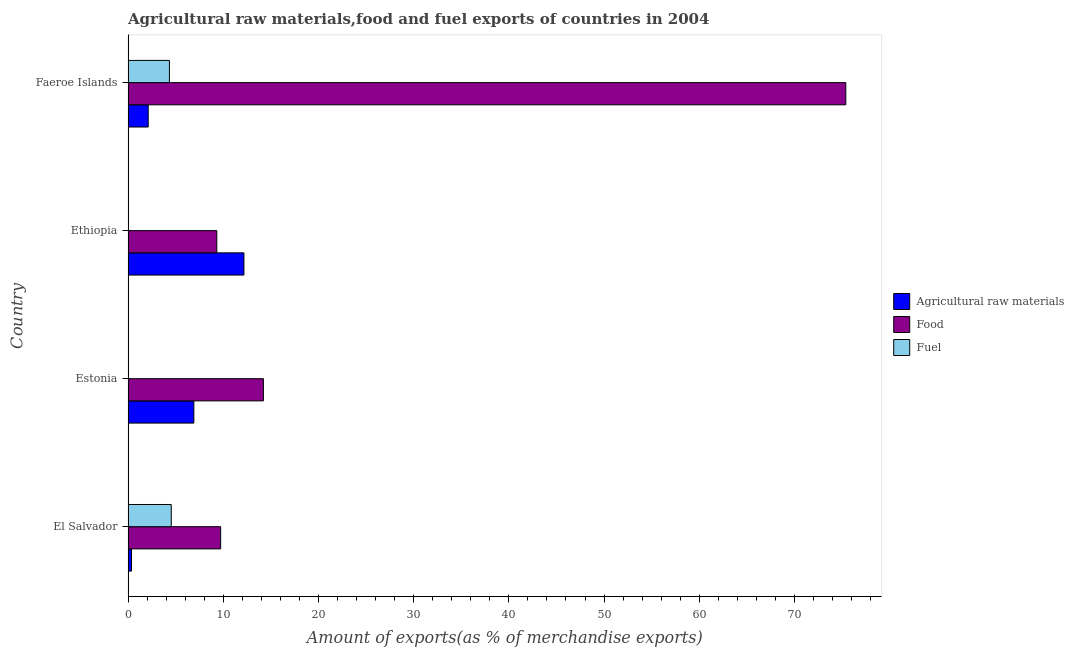Are the number of bars per tick equal to the number of legend labels?
Provide a succinct answer. Yes. Are the number of bars on each tick of the Y-axis equal?
Offer a terse response. Yes. How many bars are there on the 3rd tick from the top?
Offer a terse response. 3. How many bars are there on the 2nd tick from the bottom?
Your response must be concise. 3. What is the label of the 2nd group of bars from the top?
Offer a terse response. Ethiopia. In how many cases, is the number of bars for a given country not equal to the number of legend labels?
Your answer should be very brief. 0. What is the percentage of food exports in Faeroe Islands?
Your response must be concise. 75.39. Across all countries, what is the maximum percentage of fuel exports?
Ensure brevity in your answer.  4.54. Across all countries, what is the minimum percentage of food exports?
Provide a short and direct response. 9.32. In which country was the percentage of food exports maximum?
Ensure brevity in your answer.  Faeroe Islands. In which country was the percentage of fuel exports minimum?
Your answer should be compact. Estonia. What is the total percentage of food exports in the graph?
Give a very brief answer. 108.66. What is the difference between the percentage of raw materials exports in El Salvador and that in Faeroe Islands?
Offer a terse response. -1.76. What is the difference between the percentage of raw materials exports in Estonia and the percentage of fuel exports in Faeroe Islands?
Make the answer very short. 2.57. What is the average percentage of raw materials exports per country?
Offer a very short reply. 5.39. What is the difference between the percentage of raw materials exports and percentage of fuel exports in Estonia?
Ensure brevity in your answer.  6.91. What is the ratio of the percentage of raw materials exports in El Salvador to that in Faeroe Islands?
Your answer should be very brief. 0.17. Is the difference between the percentage of fuel exports in El Salvador and Estonia greater than the difference between the percentage of raw materials exports in El Salvador and Estonia?
Offer a terse response. Yes. What is the difference between the highest and the second highest percentage of food exports?
Make the answer very short. 61.18. What is the difference between the highest and the lowest percentage of fuel exports?
Make the answer very short. 4.53. In how many countries, is the percentage of fuel exports greater than the average percentage of fuel exports taken over all countries?
Ensure brevity in your answer.  2. Is the sum of the percentage of raw materials exports in El Salvador and Ethiopia greater than the maximum percentage of fuel exports across all countries?
Provide a succinct answer. Yes. What does the 3rd bar from the top in Ethiopia represents?
Your answer should be very brief. Agricultural raw materials. What does the 3rd bar from the bottom in Estonia represents?
Keep it short and to the point. Fuel. Are all the bars in the graph horizontal?
Offer a very short reply. Yes. What is the difference between two consecutive major ticks on the X-axis?
Your answer should be very brief. 10. Does the graph contain grids?
Make the answer very short. No. How are the legend labels stacked?
Your answer should be very brief. Vertical. What is the title of the graph?
Your answer should be compact. Agricultural raw materials,food and fuel exports of countries in 2004. What is the label or title of the X-axis?
Keep it short and to the point. Amount of exports(as % of merchandise exports). What is the label or title of the Y-axis?
Ensure brevity in your answer.  Country. What is the Amount of exports(as % of merchandise exports) in Agricultural raw materials in El Salvador?
Keep it short and to the point. 0.36. What is the Amount of exports(as % of merchandise exports) of Food in El Salvador?
Keep it short and to the point. 9.73. What is the Amount of exports(as % of merchandise exports) in Fuel in El Salvador?
Make the answer very short. 4.54. What is the Amount of exports(as % of merchandise exports) in Agricultural raw materials in Estonia?
Give a very brief answer. 6.91. What is the Amount of exports(as % of merchandise exports) in Food in Estonia?
Keep it short and to the point. 14.22. What is the Amount of exports(as % of merchandise exports) of Fuel in Estonia?
Make the answer very short. 0. What is the Amount of exports(as % of merchandise exports) of Agricultural raw materials in Ethiopia?
Provide a succinct answer. 12.17. What is the Amount of exports(as % of merchandise exports) of Food in Ethiopia?
Keep it short and to the point. 9.32. What is the Amount of exports(as % of merchandise exports) in Fuel in Ethiopia?
Provide a succinct answer. 0.01. What is the Amount of exports(as % of merchandise exports) in Agricultural raw materials in Faeroe Islands?
Keep it short and to the point. 2.12. What is the Amount of exports(as % of merchandise exports) in Food in Faeroe Islands?
Your response must be concise. 75.39. What is the Amount of exports(as % of merchandise exports) in Fuel in Faeroe Islands?
Ensure brevity in your answer.  4.34. Across all countries, what is the maximum Amount of exports(as % of merchandise exports) of Agricultural raw materials?
Ensure brevity in your answer.  12.17. Across all countries, what is the maximum Amount of exports(as % of merchandise exports) in Food?
Keep it short and to the point. 75.39. Across all countries, what is the maximum Amount of exports(as % of merchandise exports) in Fuel?
Your answer should be very brief. 4.54. Across all countries, what is the minimum Amount of exports(as % of merchandise exports) of Agricultural raw materials?
Your answer should be compact. 0.36. Across all countries, what is the minimum Amount of exports(as % of merchandise exports) of Food?
Your answer should be very brief. 9.32. Across all countries, what is the minimum Amount of exports(as % of merchandise exports) in Fuel?
Keep it short and to the point. 0. What is the total Amount of exports(as % of merchandise exports) in Agricultural raw materials in the graph?
Provide a short and direct response. 21.55. What is the total Amount of exports(as % of merchandise exports) of Food in the graph?
Provide a short and direct response. 108.66. What is the total Amount of exports(as % of merchandise exports) in Fuel in the graph?
Offer a terse response. 8.89. What is the difference between the Amount of exports(as % of merchandise exports) of Agricultural raw materials in El Salvador and that in Estonia?
Make the answer very short. -6.55. What is the difference between the Amount of exports(as % of merchandise exports) in Food in El Salvador and that in Estonia?
Make the answer very short. -4.49. What is the difference between the Amount of exports(as % of merchandise exports) of Fuel in El Salvador and that in Estonia?
Keep it short and to the point. 4.53. What is the difference between the Amount of exports(as % of merchandise exports) of Agricultural raw materials in El Salvador and that in Ethiopia?
Keep it short and to the point. -11.81. What is the difference between the Amount of exports(as % of merchandise exports) of Food in El Salvador and that in Ethiopia?
Give a very brief answer. 0.41. What is the difference between the Amount of exports(as % of merchandise exports) in Fuel in El Salvador and that in Ethiopia?
Offer a terse response. 4.53. What is the difference between the Amount of exports(as % of merchandise exports) of Agricultural raw materials in El Salvador and that in Faeroe Islands?
Give a very brief answer. -1.76. What is the difference between the Amount of exports(as % of merchandise exports) of Food in El Salvador and that in Faeroe Islands?
Provide a succinct answer. -65.67. What is the difference between the Amount of exports(as % of merchandise exports) of Fuel in El Salvador and that in Faeroe Islands?
Keep it short and to the point. 0.19. What is the difference between the Amount of exports(as % of merchandise exports) of Agricultural raw materials in Estonia and that in Ethiopia?
Provide a short and direct response. -5.26. What is the difference between the Amount of exports(as % of merchandise exports) in Food in Estonia and that in Ethiopia?
Keep it short and to the point. 4.9. What is the difference between the Amount of exports(as % of merchandise exports) in Fuel in Estonia and that in Ethiopia?
Give a very brief answer. -0. What is the difference between the Amount of exports(as % of merchandise exports) in Agricultural raw materials in Estonia and that in Faeroe Islands?
Ensure brevity in your answer.  4.79. What is the difference between the Amount of exports(as % of merchandise exports) of Food in Estonia and that in Faeroe Islands?
Provide a short and direct response. -61.18. What is the difference between the Amount of exports(as % of merchandise exports) in Fuel in Estonia and that in Faeroe Islands?
Keep it short and to the point. -4.34. What is the difference between the Amount of exports(as % of merchandise exports) of Agricultural raw materials in Ethiopia and that in Faeroe Islands?
Your answer should be compact. 10.05. What is the difference between the Amount of exports(as % of merchandise exports) of Food in Ethiopia and that in Faeroe Islands?
Offer a very short reply. -66.07. What is the difference between the Amount of exports(as % of merchandise exports) of Fuel in Ethiopia and that in Faeroe Islands?
Your answer should be very brief. -4.33. What is the difference between the Amount of exports(as % of merchandise exports) of Agricultural raw materials in El Salvador and the Amount of exports(as % of merchandise exports) of Food in Estonia?
Give a very brief answer. -13.86. What is the difference between the Amount of exports(as % of merchandise exports) of Agricultural raw materials in El Salvador and the Amount of exports(as % of merchandise exports) of Fuel in Estonia?
Provide a succinct answer. 0.35. What is the difference between the Amount of exports(as % of merchandise exports) of Food in El Salvador and the Amount of exports(as % of merchandise exports) of Fuel in Estonia?
Provide a succinct answer. 9.72. What is the difference between the Amount of exports(as % of merchandise exports) of Agricultural raw materials in El Salvador and the Amount of exports(as % of merchandise exports) of Food in Ethiopia?
Give a very brief answer. -8.96. What is the difference between the Amount of exports(as % of merchandise exports) of Agricultural raw materials in El Salvador and the Amount of exports(as % of merchandise exports) of Fuel in Ethiopia?
Offer a very short reply. 0.35. What is the difference between the Amount of exports(as % of merchandise exports) in Food in El Salvador and the Amount of exports(as % of merchandise exports) in Fuel in Ethiopia?
Your answer should be compact. 9.72. What is the difference between the Amount of exports(as % of merchandise exports) in Agricultural raw materials in El Salvador and the Amount of exports(as % of merchandise exports) in Food in Faeroe Islands?
Your answer should be very brief. -75.04. What is the difference between the Amount of exports(as % of merchandise exports) of Agricultural raw materials in El Salvador and the Amount of exports(as % of merchandise exports) of Fuel in Faeroe Islands?
Your answer should be very brief. -3.98. What is the difference between the Amount of exports(as % of merchandise exports) of Food in El Salvador and the Amount of exports(as % of merchandise exports) of Fuel in Faeroe Islands?
Provide a succinct answer. 5.38. What is the difference between the Amount of exports(as % of merchandise exports) in Agricultural raw materials in Estonia and the Amount of exports(as % of merchandise exports) in Food in Ethiopia?
Keep it short and to the point. -2.41. What is the difference between the Amount of exports(as % of merchandise exports) of Agricultural raw materials in Estonia and the Amount of exports(as % of merchandise exports) of Fuel in Ethiopia?
Keep it short and to the point. 6.9. What is the difference between the Amount of exports(as % of merchandise exports) in Food in Estonia and the Amount of exports(as % of merchandise exports) in Fuel in Ethiopia?
Make the answer very short. 14.21. What is the difference between the Amount of exports(as % of merchandise exports) in Agricultural raw materials in Estonia and the Amount of exports(as % of merchandise exports) in Food in Faeroe Islands?
Offer a very short reply. -68.48. What is the difference between the Amount of exports(as % of merchandise exports) of Agricultural raw materials in Estonia and the Amount of exports(as % of merchandise exports) of Fuel in Faeroe Islands?
Give a very brief answer. 2.57. What is the difference between the Amount of exports(as % of merchandise exports) of Food in Estonia and the Amount of exports(as % of merchandise exports) of Fuel in Faeroe Islands?
Provide a short and direct response. 9.87. What is the difference between the Amount of exports(as % of merchandise exports) of Agricultural raw materials in Ethiopia and the Amount of exports(as % of merchandise exports) of Food in Faeroe Islands?
Keep it short and to the point. -63.22. What is the difference between the Amount of exports(as % of merchandise exports) of Agricultural raw materials in Ethiopia and the Amount of exports(as % of merchandise exports) of Fuel in Faeroe Islands?
Make the answer very short. 7.83. What is the difference between the Amount of exports(as % of merchandise exports) in Food in Ethiopia and the Amount of exports(as % of merchandise exports) in Fuel in Faeroe Islands?
Keep it short and to the point. 4.98. What is the average Amount of exports(as % of merchandise exports) in Agricultural raw materials per country?
Your answer should be very brief. 5.39. What is the average Amount of exports(as % of merchandise exports) of Food per country?
Make the answer very short. 27.16. What is the average Amount of exports(as % of merchandise exports) in Fuel per country?
Your answer should be compact. 2.22. What is the difference between the Amount of exports(as % of merchandise exports) in Agricultural raw materials and Amount of exports(as % of merchandise exports) in Food in El Salvador?
Provide a short and direct response. -9.37. What is the difference between the Amount of exports(as % of merchandise exports) of Agricultural raw materials and Amount of exports(as % of merchandise exports) of Fuel in El Salvador?
Offer a very short reply. -4.18. What is the difference between the Amount of exports(as % of merchandise exports) of Food and Amount of exports(as % of merchandise exports) of Fuel in El Salvador?
Your response must be concise. 5.19. What is the difference between the Amount of exports(as % of merchandise exports) of Agricultural raw materials and Amount of exports(as % of merchandise exports) of Food in Estonia?
Offer a terse response. -7.31. What is the difference between the Amount of exports(as % of merchandise exports) of Agricultural raw materials and Amount of exports(as % of merchandise exports) of Fuel in Estonia?
Provide a succinct answer. 6.9. What is the difference between the Amount of exports(as % of merchandise exports) in Food and Amount of exports(as % of merchandise exports) in Fuel in Estonia?
Your answer should be compact. 14.21. What is the difference between the Amount of exports(as % of merchandise exports) in Agricultural raw materials and Amount of exports(as % of merchandise exports) in Food in Ethiopia?
Keep it short and to the point. 2.85. What is the difference between the Amount of exports(as % of merchandise exports) of Agricultural raw materials and Amount of exports(as % of merchandise exports) of Fuel in Ethiopia?
Your answer should be compact. 12.16. What is the difference between the Amount of exports(as % of merchandise exports) of Food and Amount of exports(as % of merchandise exports) of Fuel in Ethiopia?
Provide a short and direct response. 9.31. What is the difference between the Amount of exports(as % of merchandise exports) in Agricultural raw materials and Amount of exports(as % of merchandise exports) in Food in Faeroe Islands?
Make the answer very short. -73.28. What is the difference between the Amount of exports(as % of merchandise exports) of Agricultural raw materials and Amount of exports(as % of merchandise exports) of Fuel in Faeroe Islands?
Your answer should be very brief. -2.23. What is the difference between the Amount of exports(as % of merchandise exports) of Food and Amount of exports(as % of merchandise exports) of Fuel in Faeroe Islands?
Provide a succinct answer. 71.05. What is the ratio of the Amount of exports(as % of merchandise exports) of Agricultural raw materials in El Salvador to that in Estonia?
Give a very brief answer. 0.05. What is the ratio of the Amount of exports(as % of merchandise exports) in Food in El Salvador to that in Estonia?
Provide a short and direct response. 0.68. What is the ratio of the Amount of exports(as % of merchandise exports) in Fuel in El Salvador to that in Estonia?
Keep it short and to the point. 967.42. What is the ratio of the Amount of exports(as % of merchandise exports) in Agricultural raw materials in El Salvador to that in Ethiopia?
Provide a short and direct response. 0.03. What is the ratio of the Amount of exports(as % of merchandise exports) in Food in El Salvador to that in Ethiopia?
Your response must be concise. 1.04. What is the ratio of the Amount of exports(as % of merchandise exports) in Fuel in El Salvador to that in Ethiopia?
Give a very brief answer. 540.88. What is the ratio of the Amount of exports(as % of merchandise exports) of Agricultural raw materials in El Salvador to that in Faeroe Islands?
Offer a very short reply. 0.17. What is the ratio of the Amount of exports(as % of merchandise exports) in Food in El Salvador to that in Faeroe Islands?
Provide a short and direct response. 0.13. What is the ratio of the Amount of exports(as % of merchandise exports) of Fuel in El Salvador to that in Faeroe Islands?
Keep it short and to the point. 1.04. What is the ratio of the Amount of exports(as % of merchandise exports) of Agricultural raw materials in Estonia to that in Ethiopia?
Provide a succinct answer. 0.57. What is the ratio of the Amount of exports(as % of merchandise exports) in Food in Estonia to that in Ethiopia?
Your response must be concise. 1.53. What is the ratio of the Amount of exports(as % of merchandise exports) in Fuel in Estonia to that in Ethiopia?
Your answer should be compact. 0.56. What is the ratio of the Amount of exports(as % of merchandise exports) in Agricultural raw materials in Estonia to that in Faeroe Islands?
Ensure brevity in your answer.  3.27. What is the ratio of the Amount of exports(as % of merchandise exports) of Food in Estonia to that in Faeroe Islands?
Your answer should be compact. 0.19. What is the ratio of the Amount of exports(as % of merchandise exports) in Fuel in Estonia to that in Faeroe Islands?
Offer a terse response. 0. What is the ratio of the Amount of exports(as % of merchandise exports) in Agricultural raw materials in Ethiopia to that in Faeroe Islands?
Make the answer very short. 5.75. What is the ratio of the Amount of exports(as % of merchandise exports) in Food in Ethiopia to that in Faeroe Islands?
Provide a short and direct response. 0.12. What is the ratio of the Amount of exports(as % of merchandise exports) in Fuel in Ethiopia to that in Faeroe Islands?
Your answer should be very brief. 0. What is the difference between the highest and the second highest Amount of exports(as % of merchandise exports) in Agricultural raw materials?
Make the answer very short. 5.26. What is the difference between the highest and the second highest Amount of exports(as % of merchandise exports) of Food?
Keep it short and to the point. 61.18. What is the difference between the highest and the second highest Amount of exports(as % of merchandise exports) of Fuel?
Give a very brief answer. 0.19. What is the difference between the highest and the lowest Amount of exports(as % of merchandise exports) in Agricultural raw materials?
Make the answer very short. 11.81. What is the difference between the highest and the lowest Amount of exports(as % of merchandise exports) of Food?
Provide a short and direct response. 66.07. What is the difference between the highest and the lowest Amount of exports(as % of merchandise exports) of Fuel?
Keep it short and to the point. 4.53. 